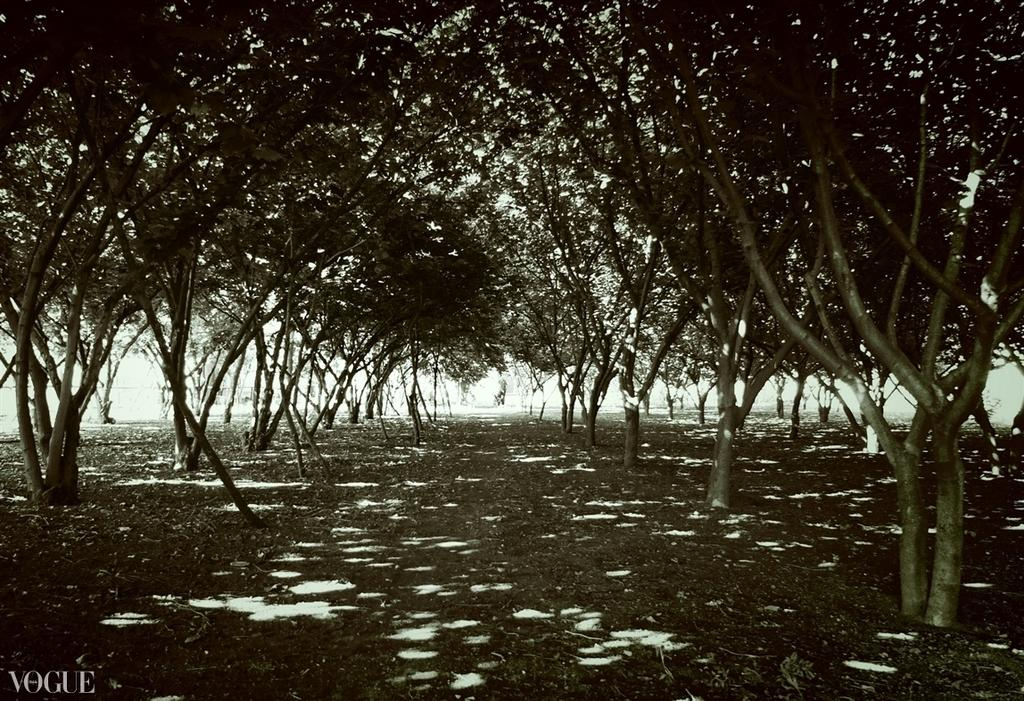What type of vegetation can be seen in the image? There are trees in the image. What can be observed on the ground in the image? There are leaves on the ground in the image. What type of button can be seen on the plants in the image? There is no button present on the plants in the image. What knowledge can be gained from observing the plants in the image? The image does not provide any specific knowledge about the plants; it simply shows their presence. 